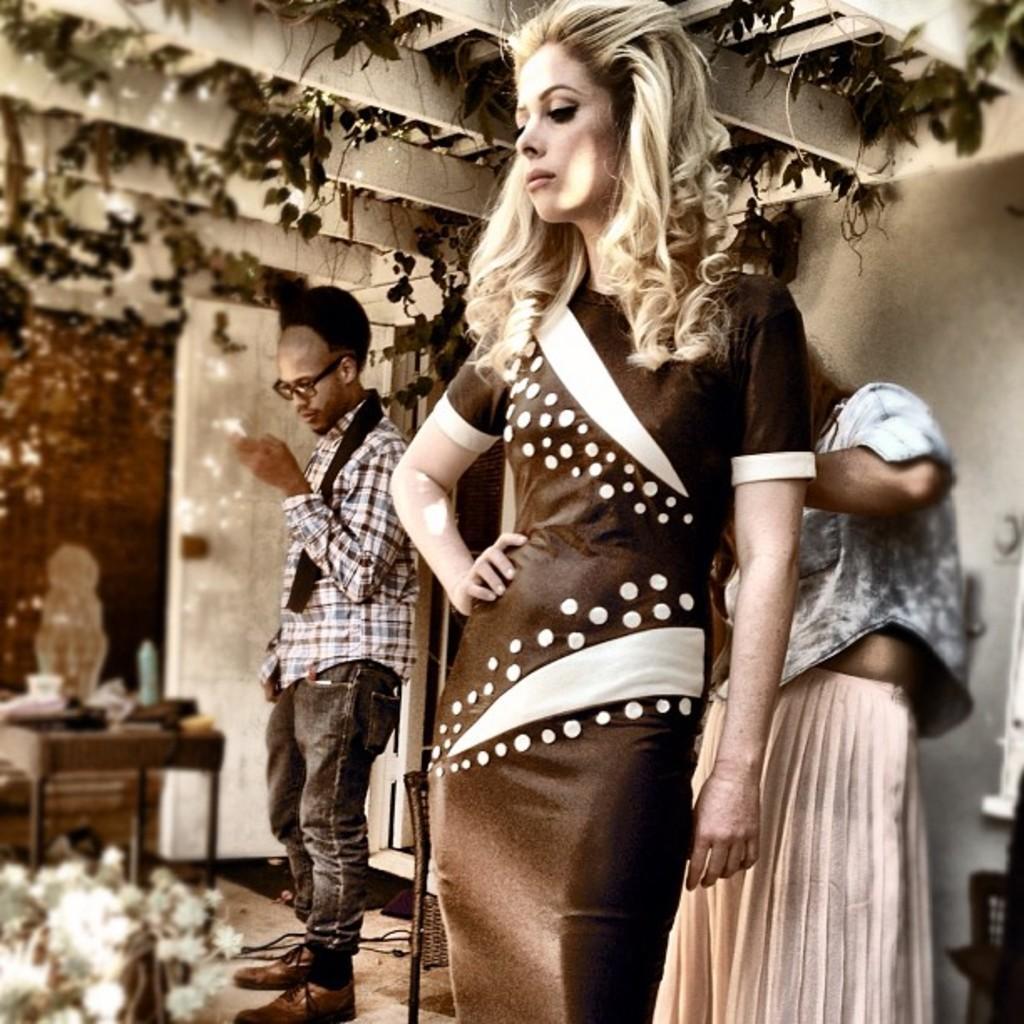How would you summarize this image in a sentence or two? In this Picture we can see a woman wearing black dress is standing and in behind a another woman is toying her dress laces, Beside her a boy wearing white and black checks shirt is seeing in his mobile, On the top we can see the vertical roof plant. On the straight font a wooden table is placed on which a candle and cup is placed with white flower bunch. 